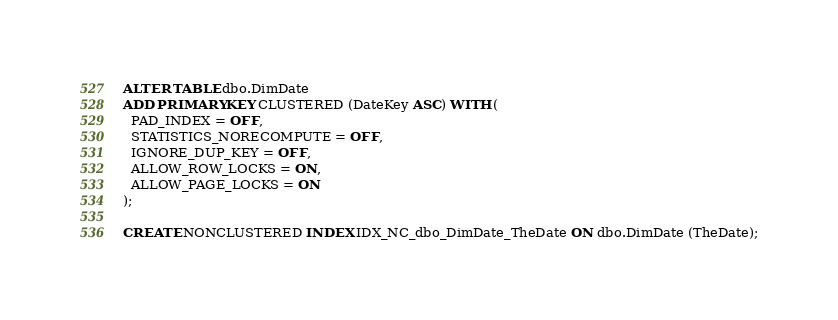Convert code to text. <code><loc_0><loc_0><loc_500><loc_500><_SQL_>ALTER TABLE dbo.DimDate
ADD PRIMARY KEY CLUSTERED (DateKey ASC) WITH (
  PAD_INDEX = OFF,
  STATISTICS_NORECOMPUTE = OFF,
  IGNORE_DUP_KEY = OFF,
  ALLOW_ROW_LOCKS = ON,
  ALLOW_PAGE_LOCKS = ON
);

CREATE NONCLUSTERED INDEX IDX_NC_dbo_DimDate_TheDate ON dbo.DimDate (TheDate);</code> 